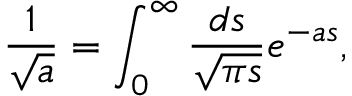Convert formula to latex. <formula><loc_0><loc_0><loc_500><loc_500>\frac { 1 } { \sqrt { a } } = \int _ { 0 } ^ { \infty } \frac { d s } { \sqrt { \pi s } } e ^ { - a s } ,</formula> 